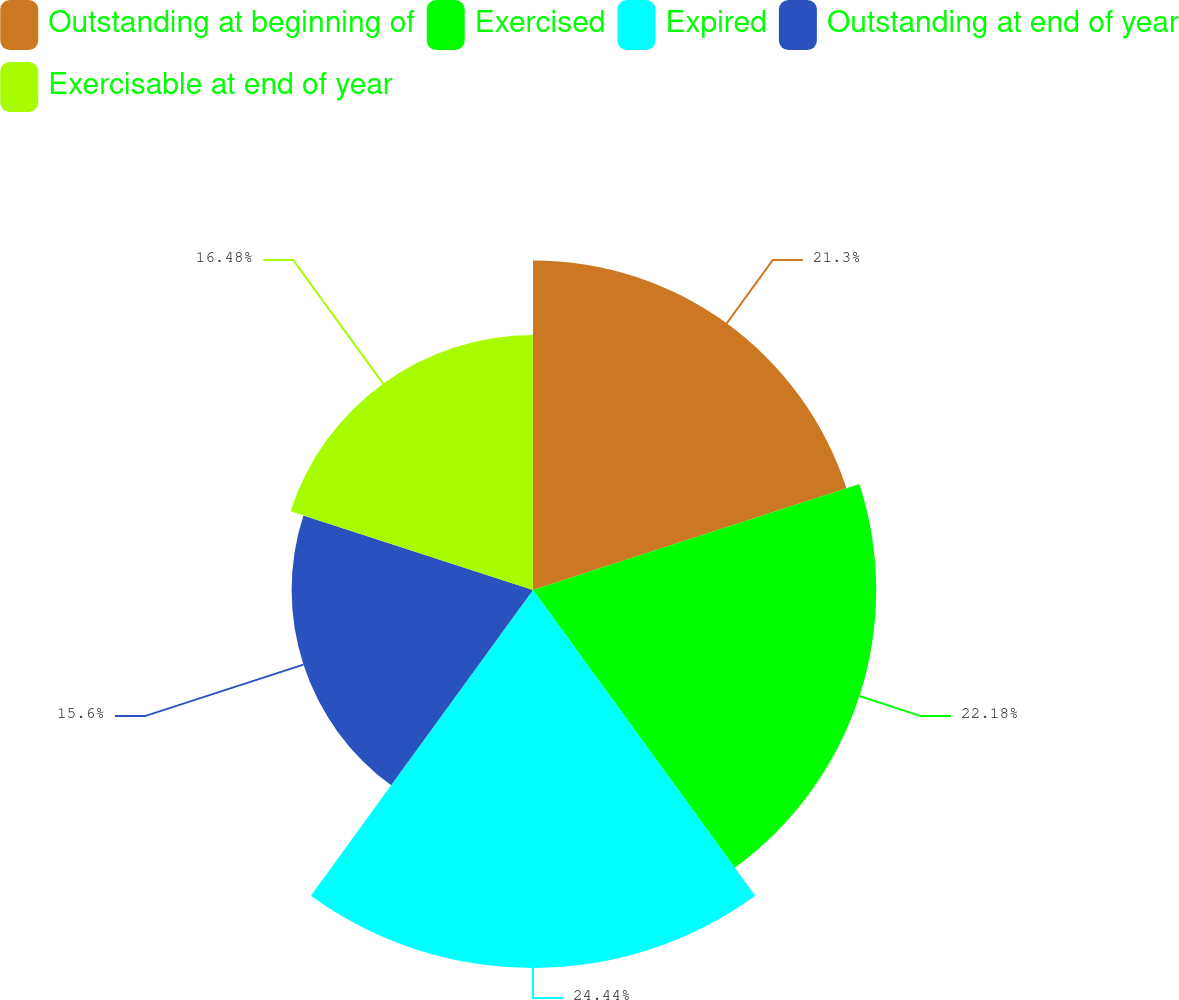Convert chart. <chart><loc_0><loc_0><loc_500><loc_500><pie_chart><fcel>Outstanding at beginning of<fcel>Exercised<fcel>Expired<fcel>Outstanding at end of year<fcel>Exercisable at end of year<nl><fcel>21.3%<fcel>22.18%<fcel>24.43%<fcel>15.6%<fcel>16.48%<nl></chart> 